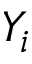Convert formula to latex. <formula><loc_0><loc_0><loc_500><loc_500>Y _ { i }</formula> 